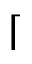<formula> <loc_0><loc_0><loc_500><loc_500>\lceil</formula> 